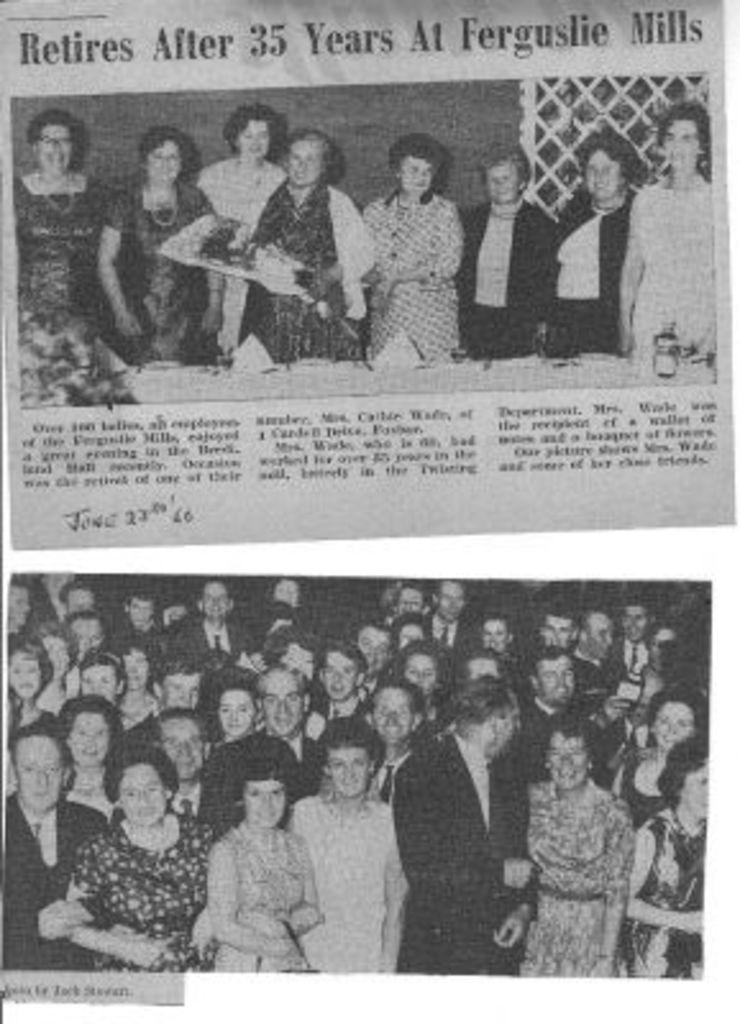What type of images are present in the image? There are newspaper photographs in the image. What is happening in the photographs? The photographs show a group of people standing over a place. What can be seen on the paper in the photographs? There is text printed on the paper in the photographs. How many houses are visible in the image? There are no houses visible in the image; it only contains newspaper photographs of a group of people standing over a place. 